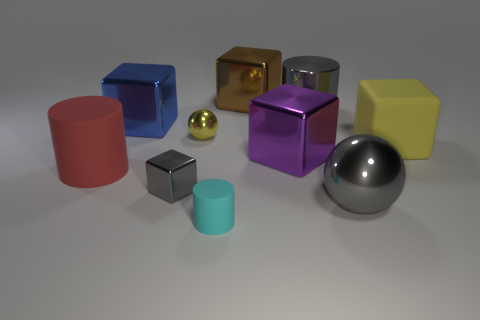Subtract 2 cubes. How many cubes are left? 3 Subtract all rubber blocks. How many blocks are left? 4 Subtract all yellow blocks. How many blocks are left? 4 Subtract all green blocks. Subtract all blue cylinders. How many blocks are left? 5 Subtract all cylinders. How many objects are left? 7 Add 1 large gray metallic spheres. How many large gray metallic spheres are left? 2 Add 9 large metal spheres. How many large metal spheres exist? 10 Subtract 1 cyan cylinders. How many objects are left? 9 Subtract all tiny gray rubber cylinders. Subtract all gray balls. How many objects are left? 9 